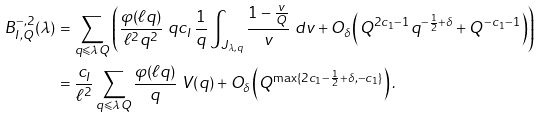Convert formula to latex. <formula><loc_0><loc_0><loc_500><loc_500>B _ { I , Q } ^ { - , 2 } ( \lambda ) & = \sum _ { q \leqslant \lambda Q } \left ( \frac { \varphi ( \ell q ) } { \ell ^ { 2 } q ^ { 2 } } \ q c _ { I } \, \frac { 1 } { q } \int _ { J _ { \lambda , q } } \frac { 1 - \frac { v } { Q } } { v } \ d v + O _ { \delta } \left ( Q ^ { 2 c _ { 1 } - 1 } q ^ { - \frac { 1 } { 2 } + \delta } + Q ^ { - c _ { 1 } - 1 } \right ) \right ) \\ & = \frac { c _ { I } } { \ell ^ { 2 } } \sum _ { q \leqslant \lambda Q } \frac { \varphi ( \ell q ) } { q } \ V ( q ) + O _ { \delta } \left ( Q ^ { \max \{ 2 c _ { 1 } - \frac { 1 } { 2 } + \delta , - c _ { 1 } \} } \right ) .</formula> 